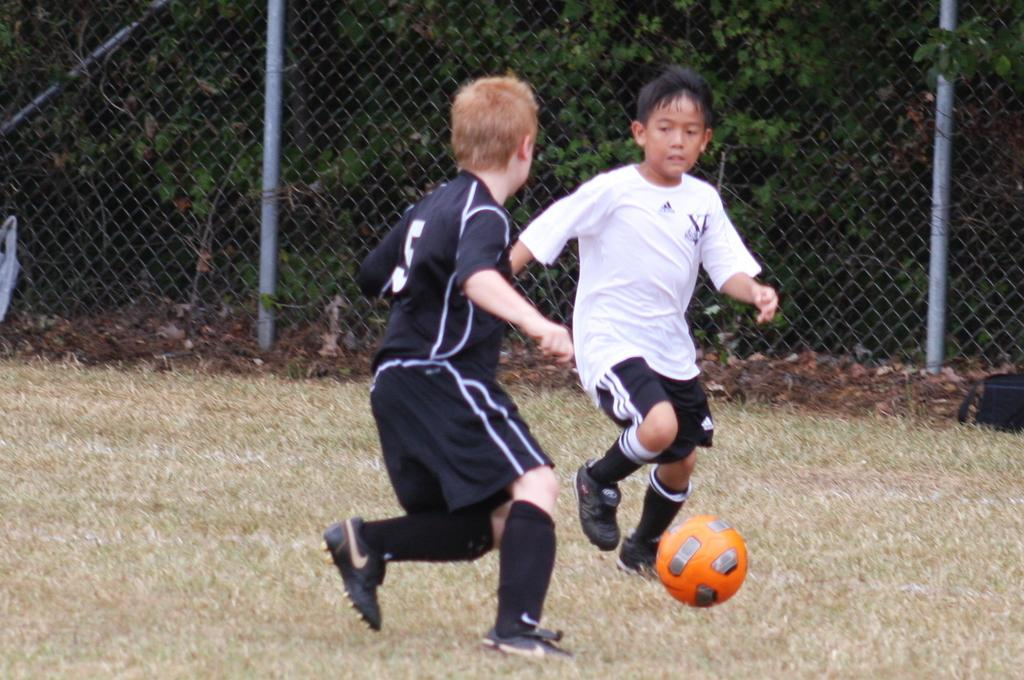How many children are in the image? There are two children in the image. What activity are the children engaged in? The children are playing football. What type of surface is the football being played on? The football is being played on a grass surface. What can be seen at the back side of the image? There is a closed mesh fencing at the back side of the image. Can you see a snail crawling on the football in the image? No, there is no snail present in the image. What type of bird is perched on the closed mesh fencing in the image? There is no bird, specifically a wren, present in the image. 